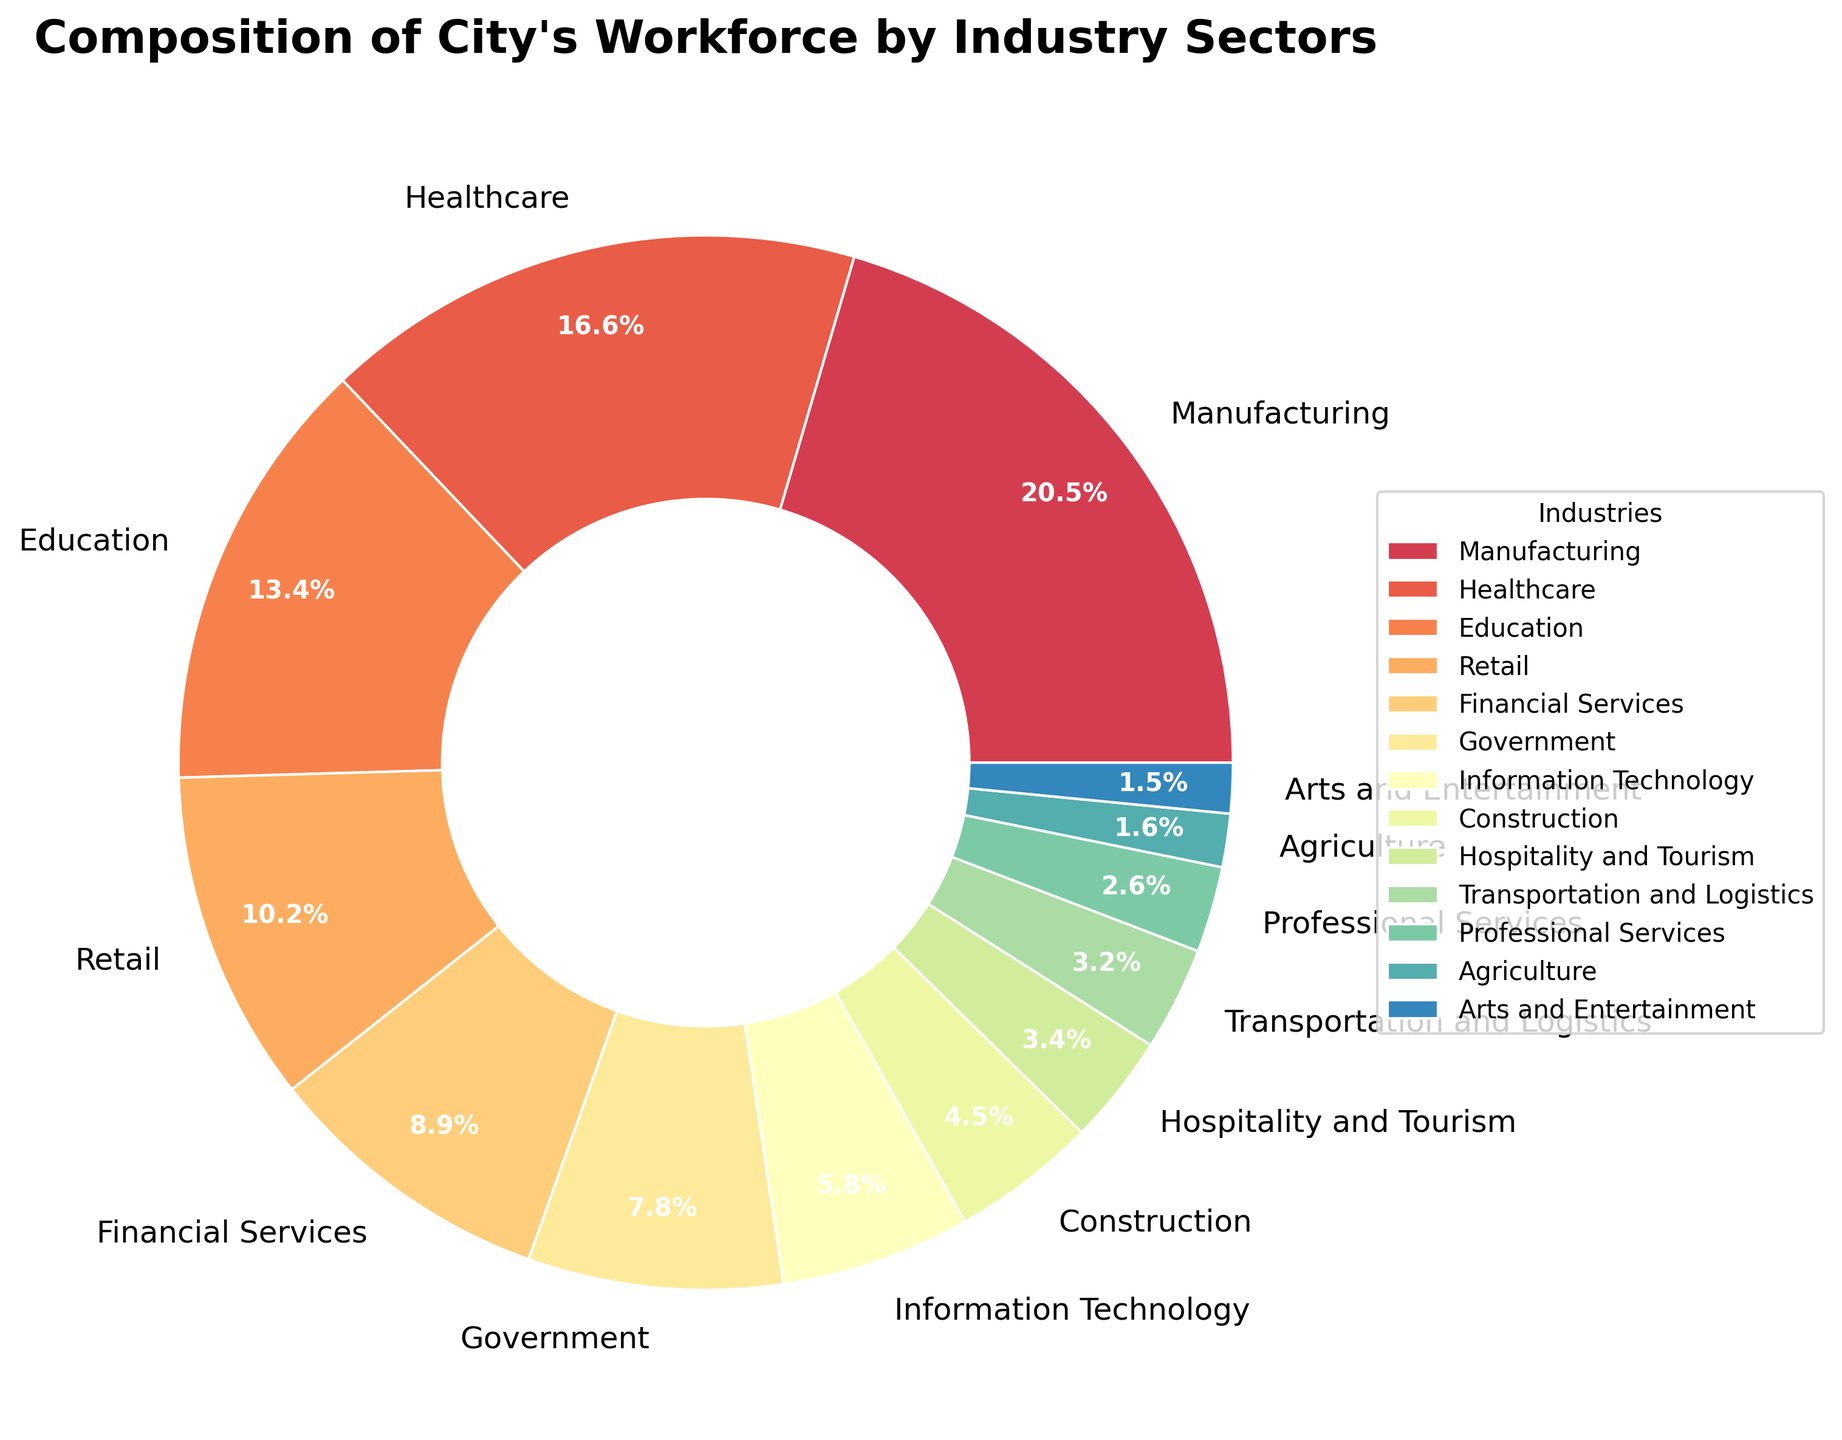Which industry sector has the largest workforce percentage? Look at the pie chart and identify the sector with the largest slice. It's Manufacturing, which occupies 22.5% of the workforce
Answer: Manufacturing What is the combined percentage of the workforce in the Healthcare and Education sectors? Add the percentage for Healthcare (18.3%) to that of Education (14.7%). 18.3 + 14.7 = 33%
Answer: 33% How does the percentage of the workforce in Financial Services compare to that in Retail? Observe the individual percentages for Financial Services (9.8%) and Retail (11.2%) and subtract one from the other. 11.2 - 9.8 = 1.4%
Answer: Retail is larger by 1.4% Which sector has a larger workforce percentage: Transportation and Logistics or Construction? Compare the percentages for Transportation and Logistics (3.5%) and Construction (4.9%). Construction has a higher value
Answer: Construction If the Transportation and Logistics and Professional Services sectors were combined, would their total percentage exceed that of the Government sector? Add the percentages of Transportation and Logistics (3.5%) and Professional Services (2.9%) and compare it with Government (8.6%). 3.5 + 2.9 = 6.4% which is less than 8.6%
Answer: No What is the difference in workforce percentage between Information Technology and Hospitality and Tourism? Subtract the percentage of Hospitality and Tourism (3.7%) from that of Information Technology (6.4%). 6.4 - 3.7 = 2.7%
Answer: 2.7% How many sectors have a workforce percentage below 5 percent? Identify and count sectors with percentages under 5%. Agriculture (1.8%), Arts and Entertainment (1.7%), Professional Services (2.9%), Transportation and Logistics (3.5%), Hospitality and Tourism (3.7%), Construction (4.9%). There are six such sectors
Answer: 6 What is the combined percentage of the smallest three sectors? Add the percentages of the three smallest sectors: Arts and Entertainment (1.7%), Agriculture (1.8%), and Professional Services (2.9%). 1.7 + 1.8 + 2.9 = 6.4%
Answer: 6.4% Which sector has a smaller workforce percentage: Agriculture or Arts and Entertainment? Compare the percentages for Agriculture (1.8%) and Arts and Entertainment (1.7%). Arts and Entertainment is smaller
Answer: Arts and Entertainment 